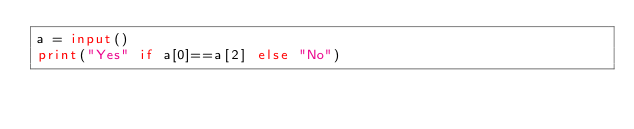<code> <loc_0><loc_0><loc_500><loc_500><_Python_>a = input()
print("Yes" if a[0]==a[2] else "No")</code> 